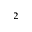Convert formula to latex. <formula><loc_0><loc_0><loc_500><loc_500>^ { 2 }</formula> 